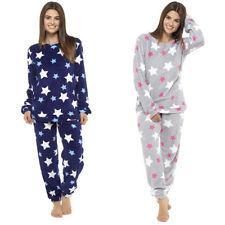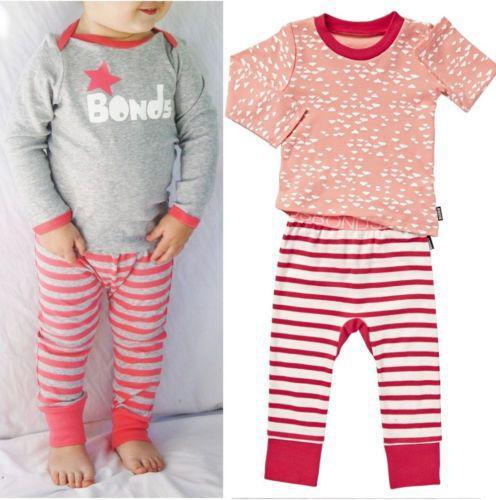The first image is the image on the left, the second image is the image on the right. Analyze the images presented: Is the assertion "Women are wearing shirts with cartoon animals sleeping on them in one of the images." valid? Answer yes or no. No. The first image is the image on the left, the second image is the image on the right. Given the left and right images, does the statement "More than one pajama set has a depiction of an animal on the top." hold true? Answer yes or no. No. 